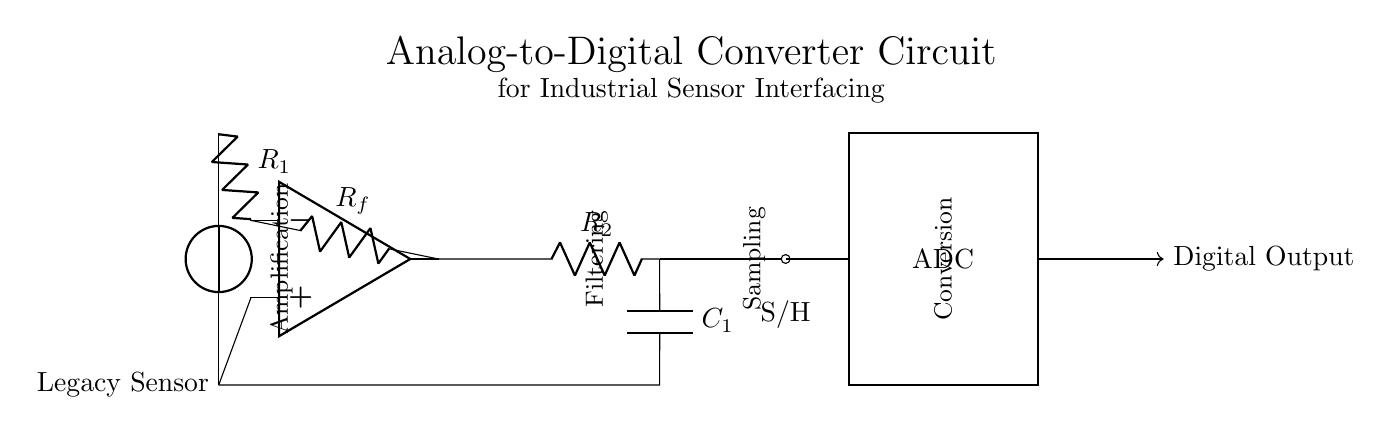What type of sensor is used in this circuit? The circuit diagram indicates a "Legacy Sensor" connected as the input. This is specified as the first label in the diagram.
Answer: Legacy Sensor What is the purpose of the operational amplifier in this circuit? The operational amplifier is used for amplification, as indicated by the label placed next to it in the circuit. It amplifies the input signal from the legacy sensor.
Answer: Amplification What is the role of the capacitor in this circuit? The capacitor is part of the low-pass filter, which smooths out fluctuations in the signal. It is connected in parallel with the resistor and labeled as C1.
Answer: Filtering What type of component is used for conversion in this circuit? The rectangular block labeled “ADC” in the diagram represents the Analog-to-Digital Converter component that performs the signal conversion from analog to digital format.
Answer: ADC How many resistors are present in this circuit? Upon analyzing the circuit diagram, there are three resistors present: R1, Rf, and R2, marked explicitly in the diagram.
Answer: Three What is the function of the sample and hold circuit? The sample and hold component captures the voltage level at a specific moment in time. This is crucial for maintaining a steady signal input into the ADC for accurate conversion.
Answer: Sampling What does the arrow indicate at the output of the ADC? The arrow denotes the direction of the digital output signal flowing out from the ADC. It signifies that this is the output point of the circuit's conversion process.
Answer: Digital Output 